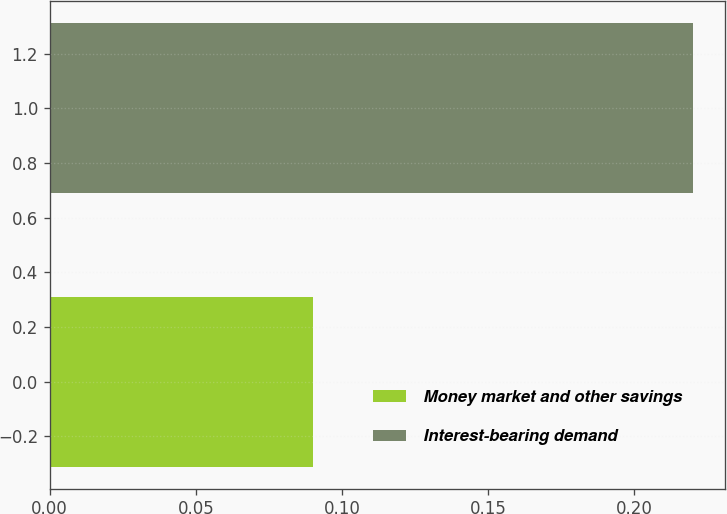Convert chart. <chart><loc_0><loc_0><loc_500><loc_500><bar_chart><fcel>Money market and other savings<fcel>Interest-bearing demand<nl><fcel>0.09<fcel>0.22<nl></chart> 